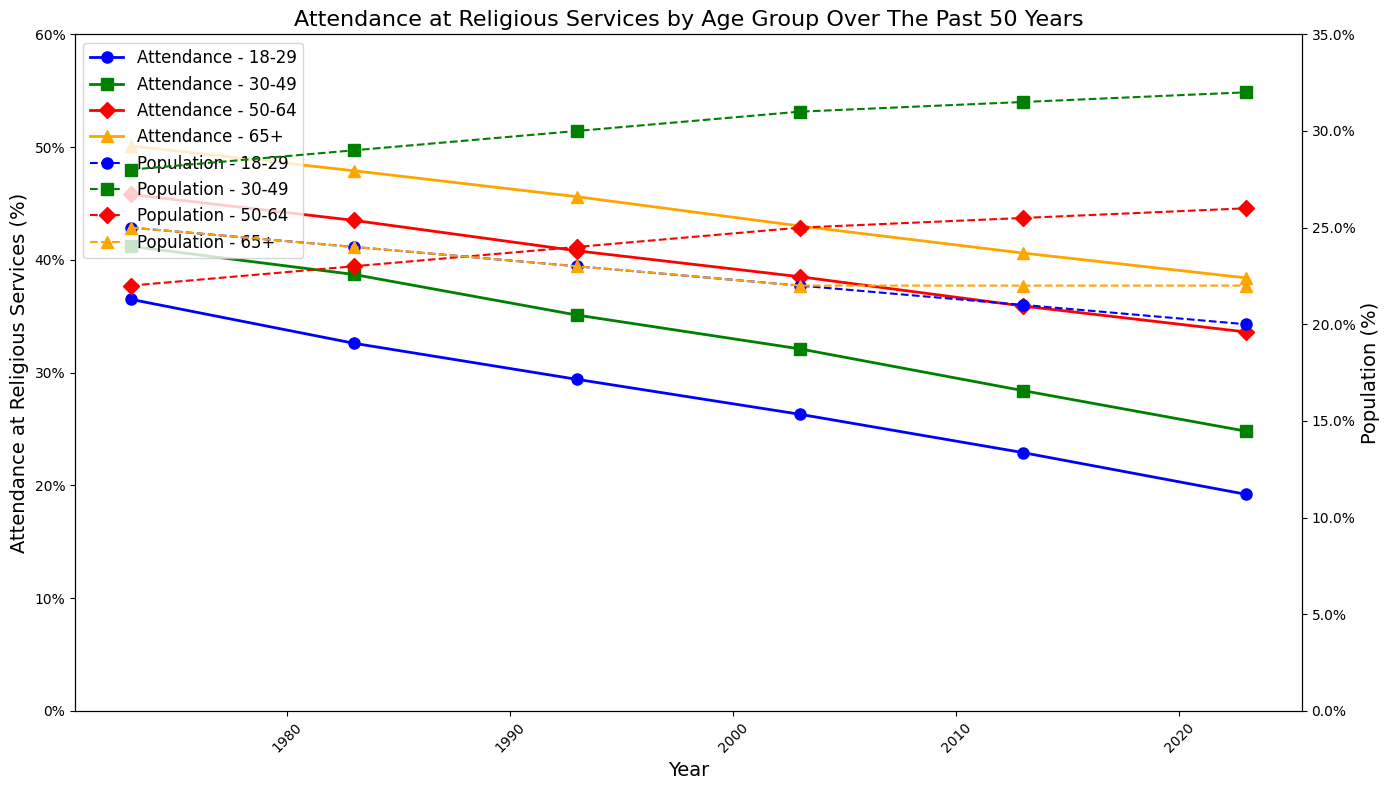Which age group had the highest attendance at religious services in 2023? To find the highest attendance, look at the top values on the left y-axis for the year 2023.
Answer: 65+ Which age group saw the largest decrease in attendance at religious services from 1973 to 2023? Find the difference in attendance percentages from 1973 to 2023 for each age group. The age group with the largest difference had the largest decrease. For instance, the 18-29 group dropped from 36.5% to 19.2%, a decrease of 17.3%.
Answer: 18-29 How did the population percentage of the 30-49 age group change from 1973 to 2023? Compare the population percentages for the 30-49 age group in 1973 and 2023 on the right y-axis.
Answer: Increased What is the average attendance at religious services for the 50-64 age group over the 50 years? Summarize the attendance percentages for the 50-64 age group across all years and divide by the number of data points (6). Calculation: (45.8 + 43.5 + 40.8 + 38.5 + 35.9 + 33.6) / 6.
Answer: 39.68% Did the 18-29 age group population percentage ever surpass the 65+ age group’s attendance at religious services? Compare the 18-29 population percentages with 65+ attendance percentages across all years. Note that 25% in 1973 for the 18-29 group equals or surpasses 24% for the 65+ group's attendance in 2013 and 2023.
Answer: Yes Which year showed the smallest difference between the population percentage of the 30-49 age group and their attendance at religious services? Calculate the difference for each year: for example, in 1973, it's 28% - 41.2% = -13.2%, and find the year with the smallest absolute value.
Answer: 2003 What was the sum of the attendance at religious services for the 65+ group in 1983 and 2013? Simply add the attendance at religious services percentages for the 65+ group in 1983 (47.9%) and 2013 (40.6%).
Answer: 88.5% By how much did the attendance at religious services for the 30-49 age group decline from 2003 to 2023? Subtract the attendance percentage in 2023 (24.8%) from that of 2003 (32.1%).
Answer: 7.3% What color represents the 18-29 age group’s attendance at religious services? Identify the color of the line representing the 18-29 age group’s attendance on the left y-axis.
Answer: Blue Which age group’s population percentage had the least change over 50 years? Compare the population percentages for each age group from 1973 to 2023: for instance, 65+ had slight changes from 25% to 22%, hence the least change.
Answer: 65+ 